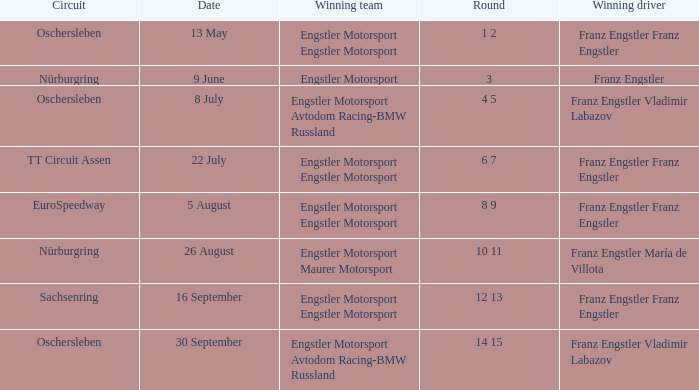What Round was the Winning Team Engstler Motorsport Maurer Motorsport? 10 11. 